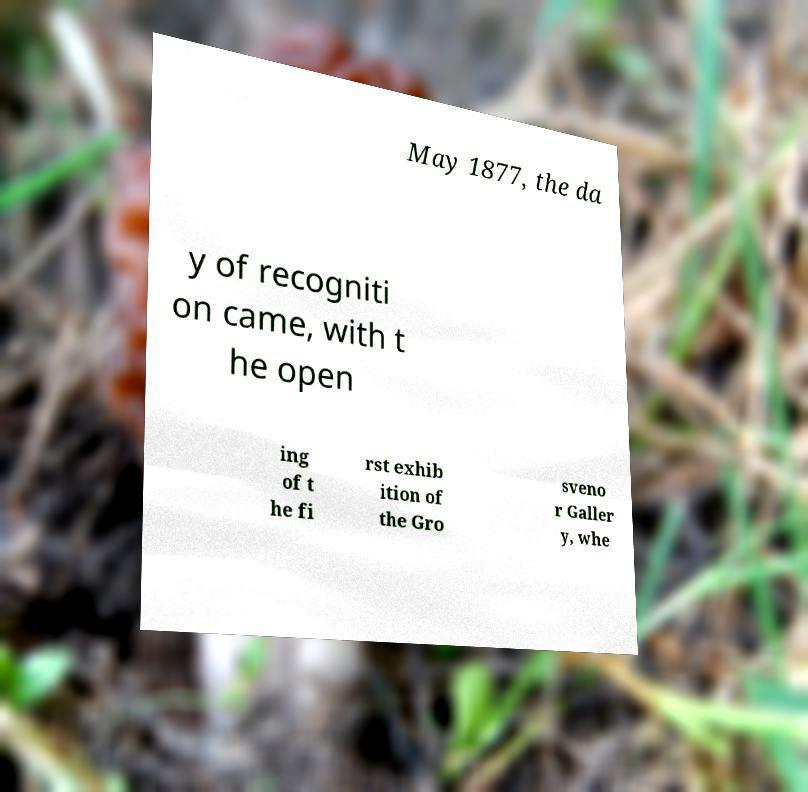There's text embedded in this image that I need extracted. Can you transcribe it verbatim? May 1877, the da y of recogniti on came, with t he open ing of t he fi rst exhib ition of the Gro sveno r Galler y, whe 